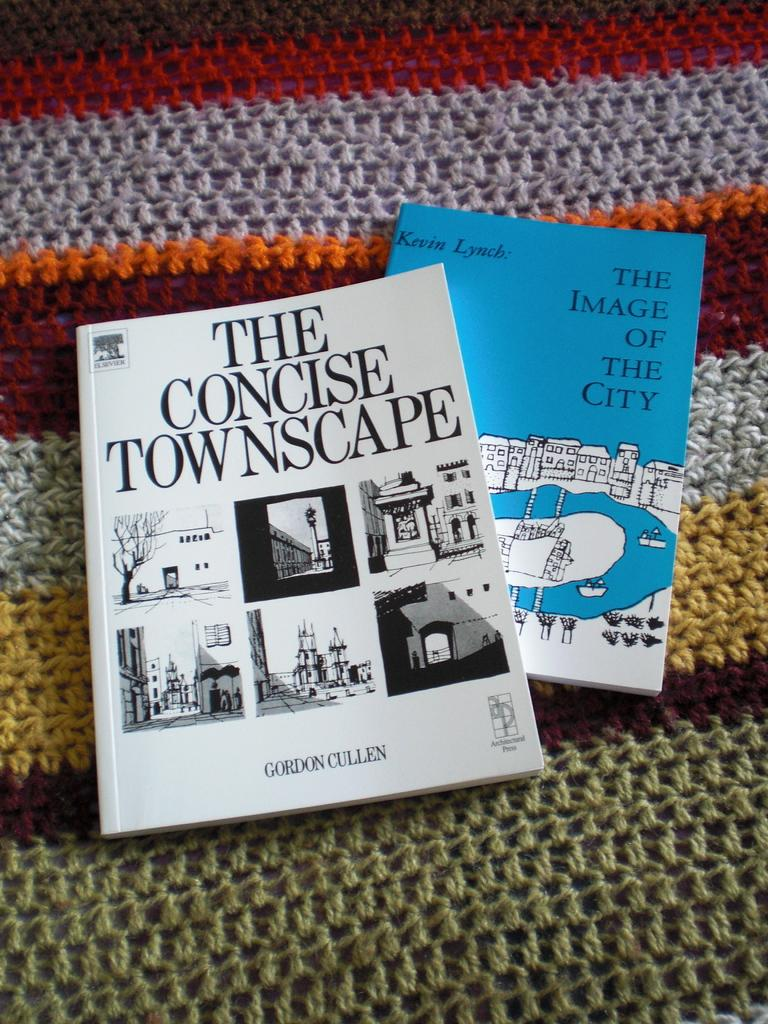<image>
Provide a brief description of the given image. A book called The Concise Townscape and another called The Image of the City rest on top of a knitted afghan. 